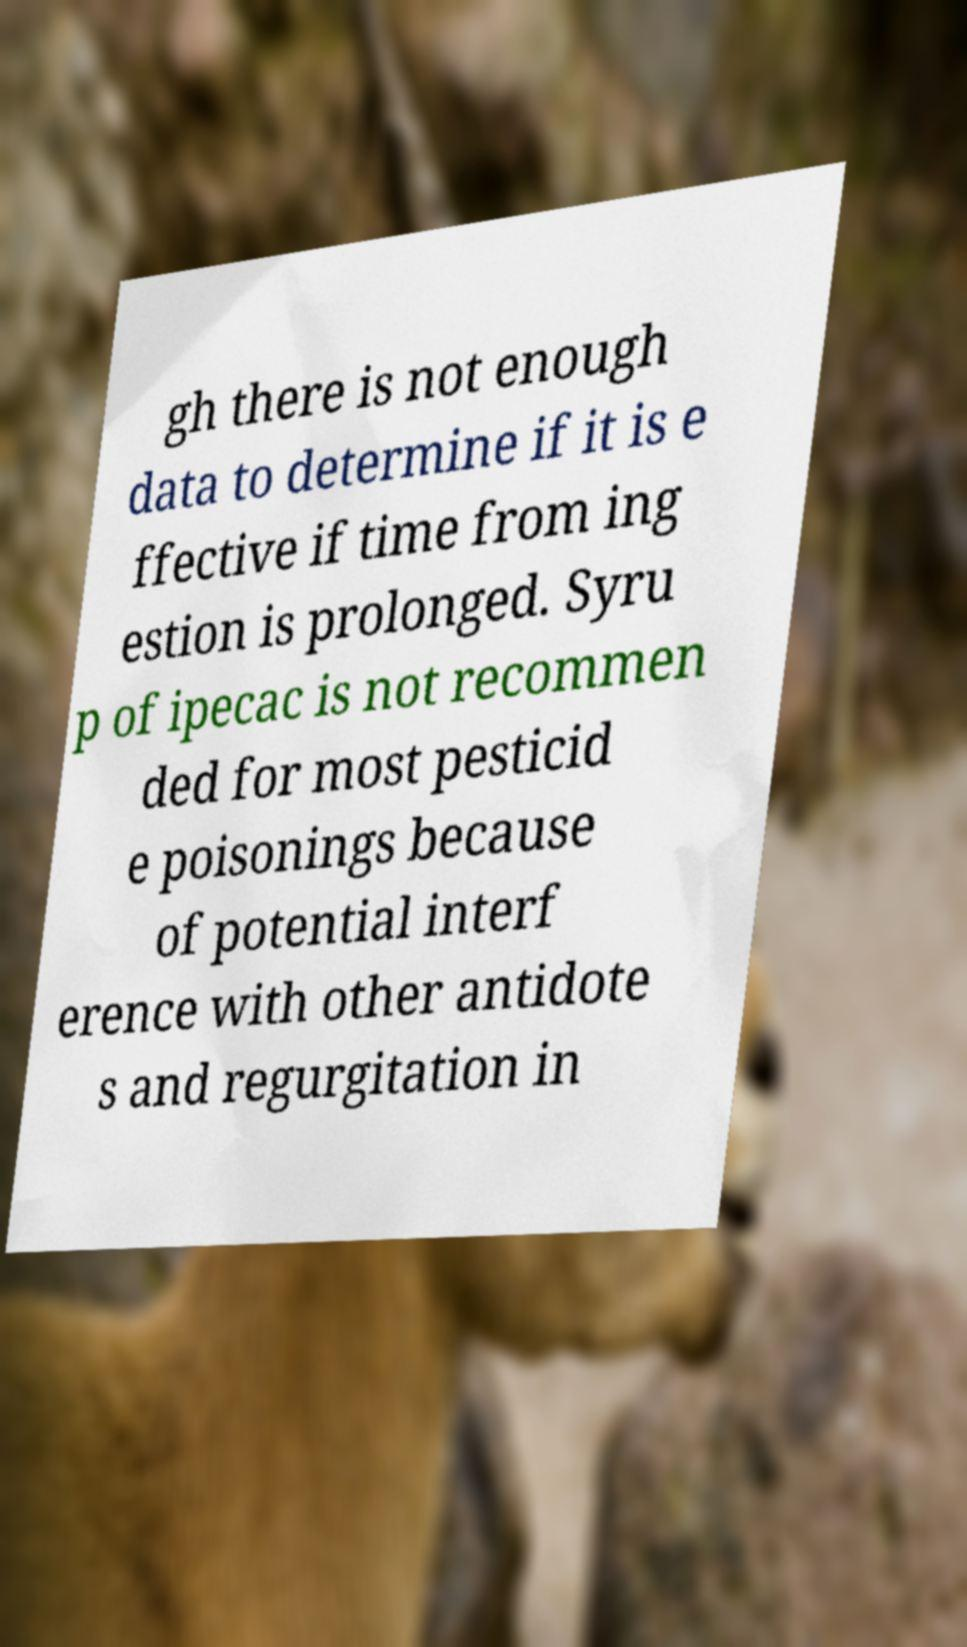Could you extract and type out the text from this image? gh there is not enough data to determine if it is e ffective if time from ing estion is prolonged. Syru p of ipecac is not recommen ded for most pesticid e poisonings because of potential interf erence with other antidote s and regurgitation in 